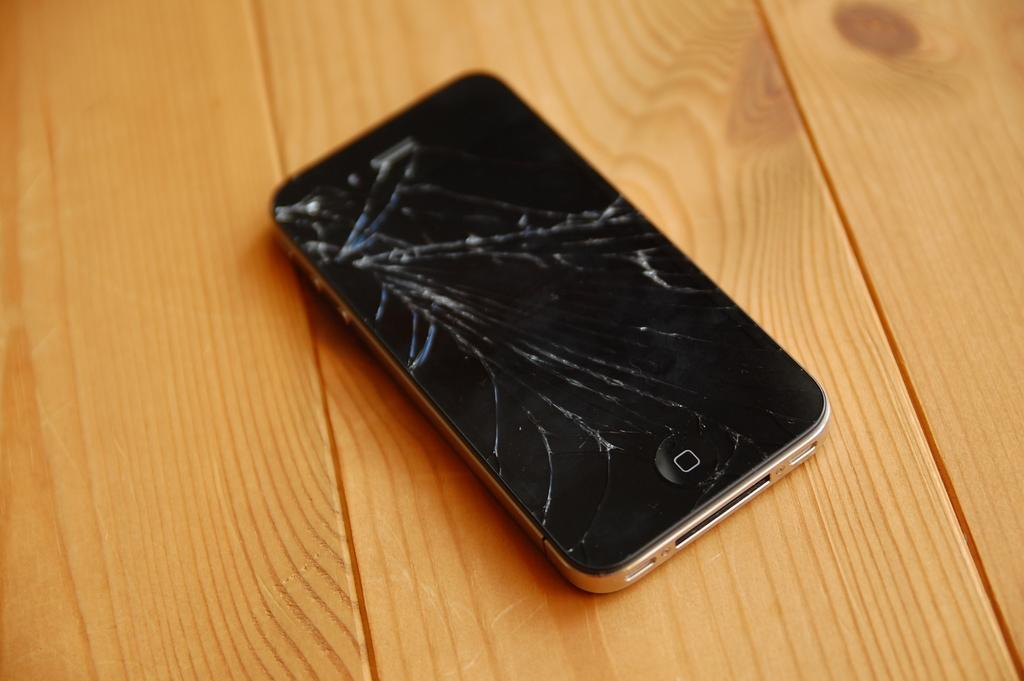<image>
Share a concise interpretation of the image provided. A broken phone on a wooden floor has an O on its bottom. 